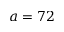<formula> <loc_0><loc_0><loc_500><loc_500>a = 7 2</formula> 